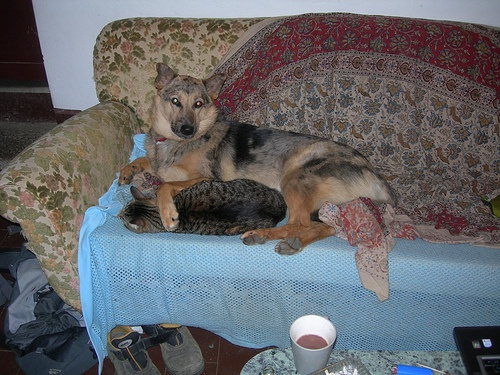Describe the objects in this image and their specific colors. I can see couch in gray, black, and maroon tones, dog in black, gray, and maroon tones, backpack in black, darkblue, and gray tones, cat in black and gray tones, and cup in black, white, darkgray, and gray tones in this image. 